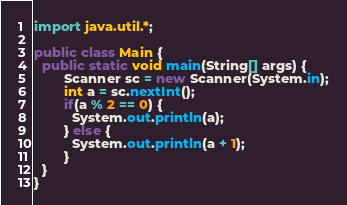Convert code to text. <code><loc_0><loc_0><loc_500><loc_500><_Java_>import java.util.*;

public class Main {
  public static void main(String[] args) {
    	Scanner sc = new Scanner(System.in);
    	int a = sc.nextInt();
    	if(a % 2 == 0) {
          System.out.println(a);
        } else {
          System.out.println(a + 1);
        }
  }
}</code> 